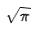Convert formula to latex. <formula><loc_0><loc_0><loc_500><loc_500>\sqrt { \pi }</formula> 